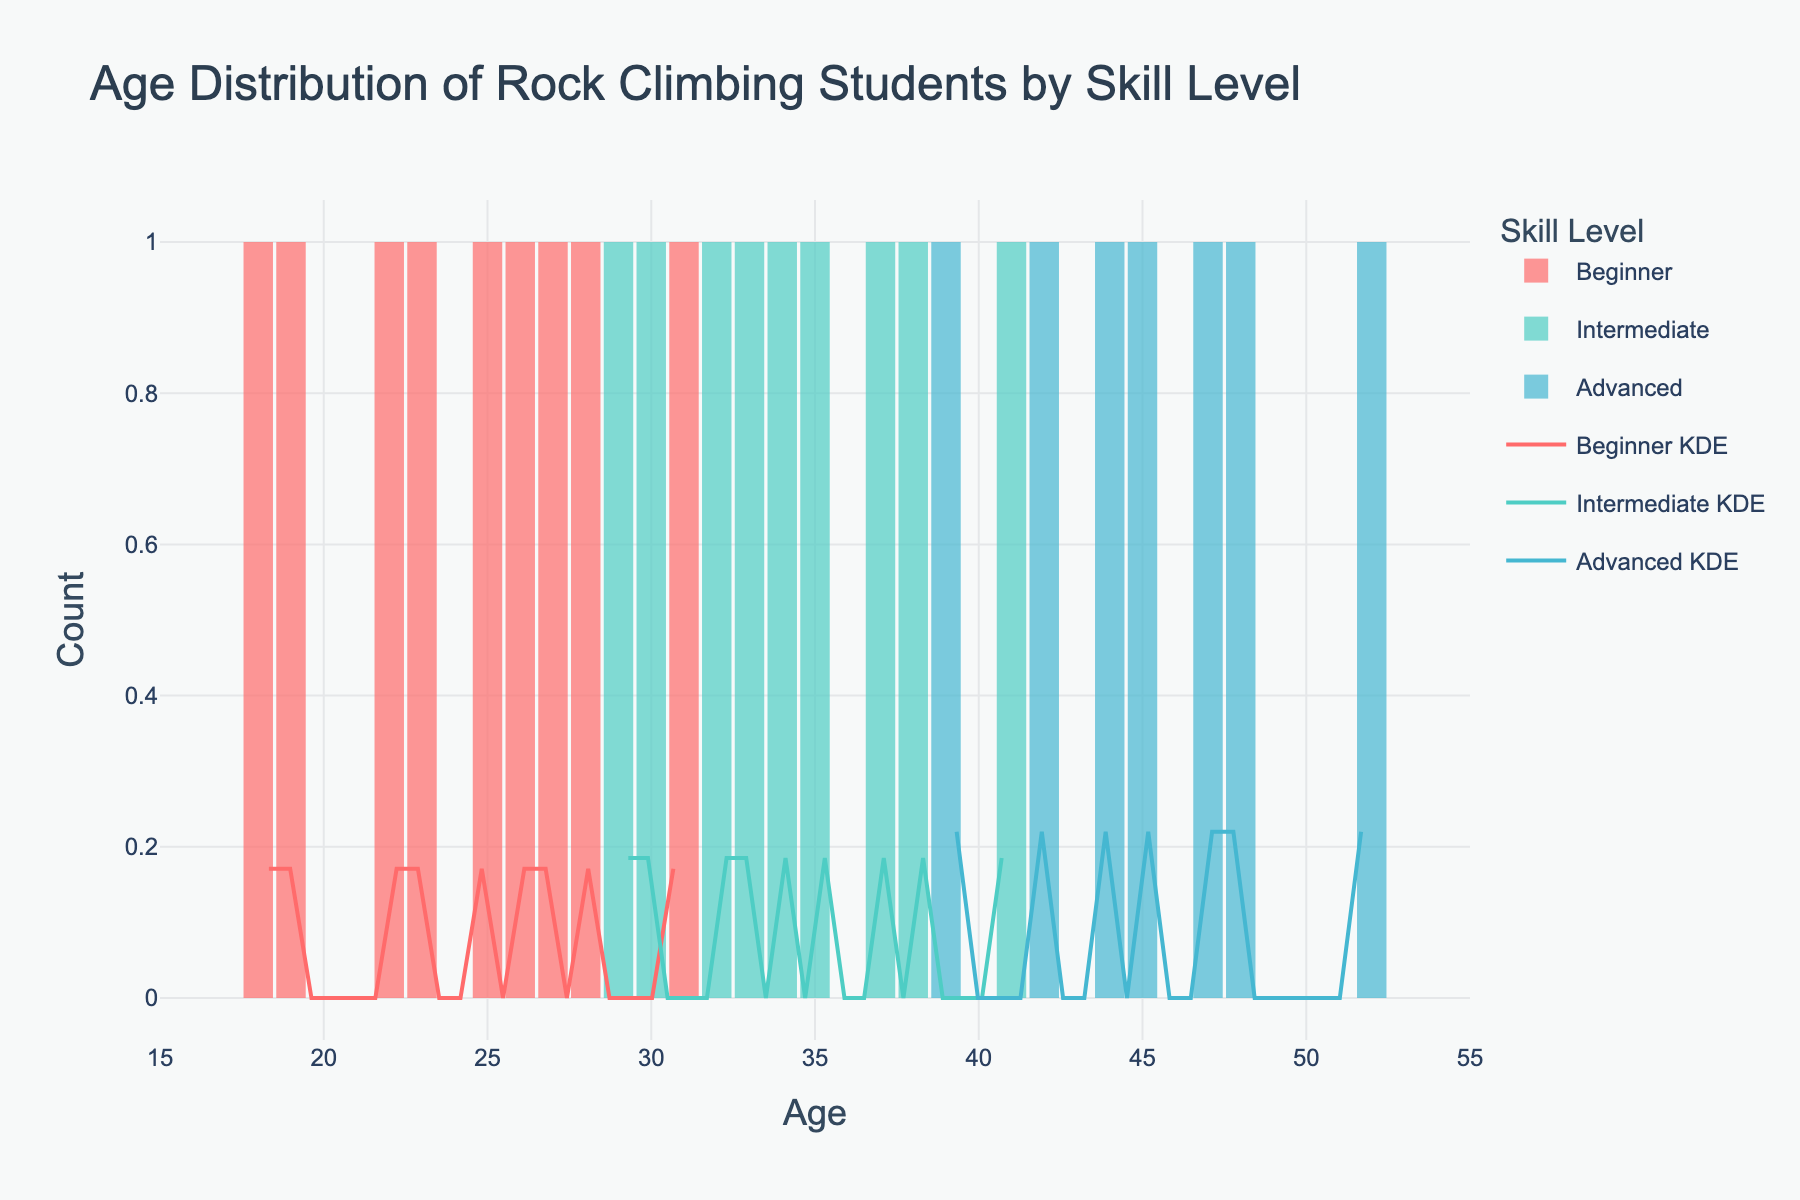What is the title of the figure? The title is displayed at the top of the plot and summarizes the content of the figure. The title here is written in a larger font compared to other text in the figure.
Answer: Age Distribution of Rock Climbing Students by Skill Level What are the skill levels mentioned in the figure? The skill levels can be identified from the legend, which uses different colors to represent each skill level.
Answer: Beginner, Intermediate, Advanced Which age group has the highest count for the Advanced skill level? By observing the histogram bars, we can see which age ranges have the tallest bars for the Advanced skill level. The Advanced level is represented by the color corresponding to its legend entry.
Answer: 45-50 How do the KDE curves for Intermediate and Advanced skill levels compare around the age of 35? By examining the KDE (density) curves, one can compare the heights of the curves at specific age values. Look at where both KDE curves intersect around the age of 35.
Answer: The Intermediate KDE is higher than the Advanced KDE At which age range does the Beginner skill level have the most frequent occurrences? One can identify this by finding the tallest histogram bar for the Beginner skill level. Look for the specific age range on the x-axis.
Answer: 25-30 Which skill level has the widest age distribution? By evaluating the total spread of the histograms (the range covered by the bars) for each skill level, we can determine which has the widest distribution. Examine where the bars for each skill level start and end on the x-axis.
Answer: Advanced How does the count of Intermediate climbers aged 30 compare to those aged 35? We compare the height of the histogram bars for Intermediate climbers at the ages of 30 and 35.
Answer: The count at age 30 is lower than that at age 35 What is the approximate range of ages for Advanced climbers as shown in the histogram? The age range is determined by noting where the histogram bars for the Advanced climbers start and stop on the x-axis.
Answer: 39-52 Are there any age groups where all three skill levels overlap significantly in the KDE curves? By observing the KDE curves, we can identify points where curves for Beginner, Intermediate, and Advanced levels are close together or intersect.
Answer: Around ages 38-39 Which skill level shows the most peaked KDE curve? The most peaked KDE curve is the one that reaches the highest point. Examine all KDE curves and compare their maximum heights.
Answer: Beginner 